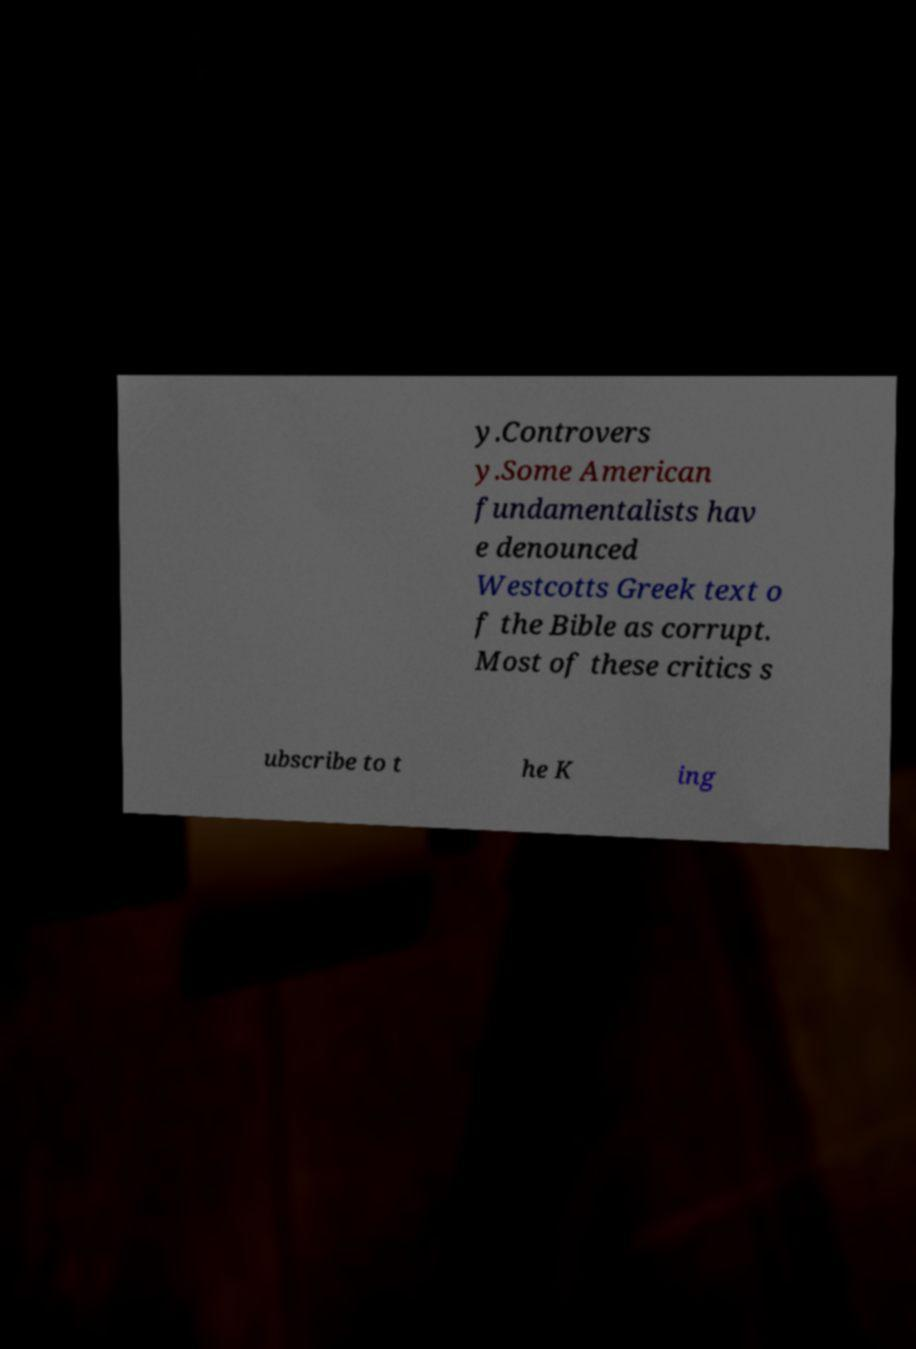Could you extract and type out the text from this image? y.Controvers y.Some American fundamentalists hav e denounced Westcotts Greek text o f the Bible as corrupt. Most of these critics s ubscribe to t he K ing 